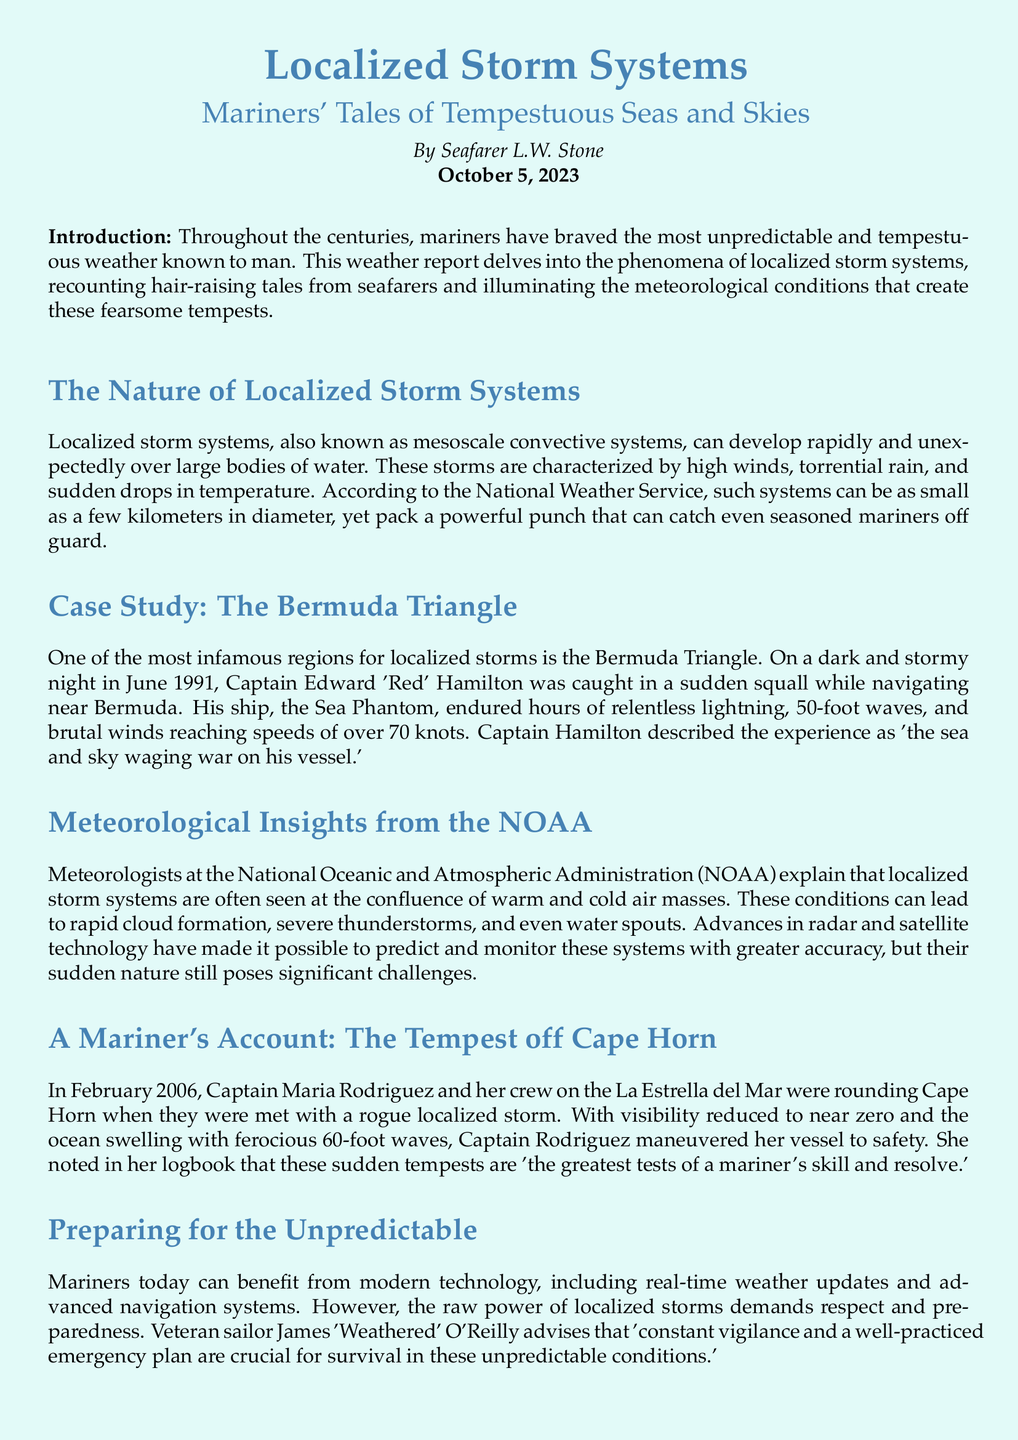What is the date of the report? The report is dated October 5, 2023 as mentioned at the beginning of the document.
Answer: October 5, 2023 Who wrote the report? The author of the report is identified as Seafarer L.W. Stone in the introductory section.
Answer: Seafarer L.W. Stone What is one of the characteristics of localized storm systems? According to the document, one characteristic of localized storm systems is high winds, torrential rain, and sudden drops in temperature.
Answer: High winds What is a notable case study mentioned in the document? The document highlights the Bermuda Triangle as a notable case study regarding localized storms.
Answer: The Bermuda Triangle What was Captain Edward 'Red' Hamilton's ship called? The ship's name that Captain Hamilton was navigating is mentioned as the Sea Phantom.
Answer: Sea Phantom How high were the waves described by Captain Maria Rodriguez? The document specifies that the waves were ferocious and reached heights of 60 feet during the storm off Cape Horn.
Answer: 60 feet What is one piece of advice given to mariners facing localized storms? Veteran sailor James 'Weathered' O'Reilly advises that constant vigilance and having a well-practiced emergency plan are crucial for survival in such conditions.
Answer: Constant vigilance What meteorological organization is referenced in the report? The report references the National Oceanic and Atmospheric Administration, known as NOAA.
Answer: NOAA What can localized storm systems lead to? The document indicates that these storm systems can lead to rapid cloud formation, severe thunderstorms, and even water spouts.
Answer: Water spouts 